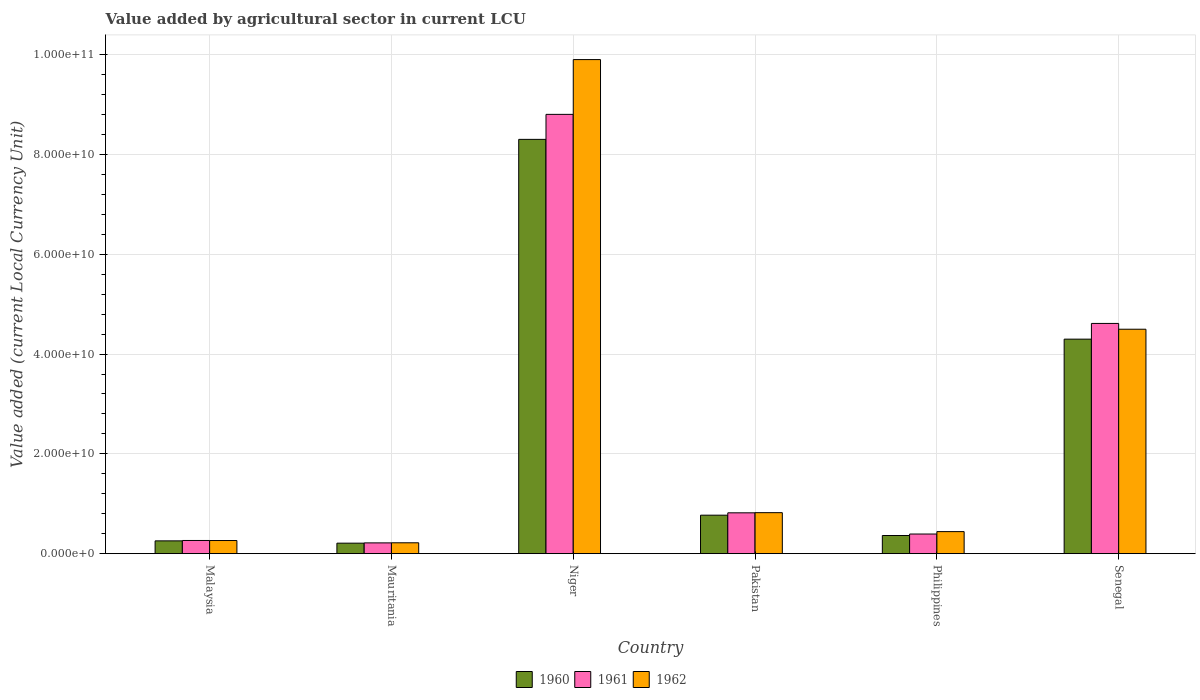How many different coloured bars are there?
Provide a short and direct response. 3. How many bars are there on the 6th tick from the right?
Your answer should be compact. 3. What is the label of the 3rd group of bars from the left?
Keep it short and to the point. Niger. In how many cases, is the number of bars for a given country not equal to the number of legend labels?
Your response must be concise. 0. What is the value added by agricultural sector in 1962 in Malaysia?
Keep it short and to the point. 2.63e+09. Across all countries, what is the maximum value added by agricultural sector in 1960?
Your answer should be very brief. 8.30e+1. Across all countries, what is the minimum value added by agricultural sector in 1962?
Your answer should be very brief. 2.18e+09. In which country was the value added by agricultural sector in 1962 maximum?
Give a very brief answer. Niger. In which country was the value added by agricultural sector in 1961 minimum?
Provide a short and direct response. Mauritania. What is the total value added by agricultural sector in 1961 in the graph?
Make the answer very short. 1.51e+11. What is the difference between the value added by agricultural sector in 1962 in Pakistan and that in Senegal?
Offer a very short reply. -3.68e+1. What is the difference between the value added by agricultural sector in 1960 in Malaysia and the value added by agricultural sector in 1961 in Pakistan?
Make the answer very short. -5.62e+09. What is the average value added by agricultural sector in 1960 per country?
Ensure brevity in your answer.  2.37e+1. What is the difference between the value added by agricultural sector of/in 1962 and value added by agricultural sector of/in 1961 in Pakistan?
Give a very brief answer. 3.20e+07. What is the ratio of the value added by agricultural sector in 1962 in Mauritania to that in Senegal?
Provide a short and direct response. 0.05. Is the value added by agricultural sector in 1961 in Mauritania less than that in Senegal?
Offer a terse response. Yes. Is the difference between the value added by agricultural sector in 1962 in Malaysia and Mauritania greater than the difference between the value added by agricultural sector in 1961 in Malaysia and Mauritania?
Offer a terse response. No. What is the difference between the highest and the second highest value added by agricultural sector in 1962?
Make the answer very short. 5.40e+1. What is the difference between the highest and the lowest value added by agricultural sector in 1960?
Give a very brief answer. 8.09e+1. What does the 2nd bar from the left in Niger represents?
Offer a terse response. 1961. Is it the case that in every country, the sum of the value added by agricultural sector in 1962 and value added by agricultural sector in 1961 is greater than the value added by agricultural sector in 1960?
Give a very brief answer. Yes. Are all the bars in the graph horizontal?
Provide a short and direct response. No. How many countries are there in the graph?
Give a very brief answer. 6. Are the values on the major ticks of Y-axis written in scientific E-notation?
Ensure brevity in your answer.  Yes. Does the graph contain grids?
Make the answer very short. Yes. Where does the legend appear in the graph?
Your response must be concise. Bottom center. What is the title of the graph?
Give a very brief answer. Value added by agricultural sector in current LCU. Does "1967" appear as one of the legend labels in the graph?
Provide a short and direct response. No. What is the label or title of the Y-axis?
Give a very brief answer. Value added (current Local Currency Unit). What is the Value added (current Local Currency Unit) of 1960 in Malaysia?
Offer a very short reply. 2.56e+09. What is the Value added (current Local Currency Unit) of 1961 in Malaysia?
Provide a short and direct response. 2.64e+09. What is the Value added (current Local Currency Unit) in 1962 in Malaysia?
Offer a terse response. 2.63e+09. What is the Value added (current Local Currency Unit) of 1960 in Mauritania?
Offer a terse response. 2.10e+09. What is the Value added (current Local Currency Unit) of 1961 in Mauritania?
Keep it short and to the point. 2.16e+09. What is the Value added (current Local Currency Unit) in 1962 in Mauritania?
Your answer should be compact. 2.18e+09. What is the Value added (current Local Currency Unit) in 1960 in Niger?
Make the answer very short. 8.30e+1. What is the Value added (current Local Currency Unit) in 1961 in Niger?
Make the answer very short. 8.80e+1. What is the Value added (current Local Currency Unit) in 1962 in Niger?
Make the answer very short. 9.90e+1. What is the Value added (current Local Currency Unit) in 1960 in Pakistan?
Keep it short and to the point. 7.71e+09. What is the Value added (current Local Currency Unit) of 1961 in Pakistan?
Offer a very short reply. 8.18e+09. What is the Value added (current Local Currency Unit) in 1962 in Pakistan?
Your answer should be compact. 8.22e+09. What is the Value added (current Local Currency Unit) of 1960 in Philippines?
Give a very brief answer. 3.64e+09. What is the Value added (current Local Currency Unit) of 1961 in Philippines?
Provide a short and direct response. 3.94e+09. What is the Value added (current Local Currency Unit) in 1962 in Philippines?
Offer a terse response. 4.42e+09. What is the Value added (current Local Currency Unit) of 1960 in Senegal?
Ensure brevity in your answer.  4.30e+1. What is the Value added (current Local Currency Unit) of 1961 in Senegal?
Offer a terse response. 4.61e+1. What is the Value added (current Local Currency Unit) of 1962 in Senegal?
Your answer should be very brief. 4.50e+1. Across all countries, what is the maximum Value added (current Local Currency Unit) of 1960?
Provide a short and direct response. 8.30e+1. Across all countries, what is the maximum Value added (current Local Currency Unit) of 1961?
Make the answer very short. 8.80e+1. Across all countries, what is the maximum Value added (current Local Currency Unit) of 1962?
Provide a short and direct response. 9.90e+1. Across all countries, what is the minimum Value added (current Local Currency Unit) of 1960?
Your answer should be compact. 2.10e+09. Across all countries, what is the minimum Value added (current Local Currency Unit) of 1961?
Provide a short and direct response. 2.16e+09. Across all countries, what is the minimum Value added (current Local Currency Unit) in 1962?
Your answer should be very brief. 2.18e+09. What is the total Value added (current Local Currency Unit) in 1960 in the graph?
Your answer should be compact. 1.42e+11. What is the total Value added (current Local Currency Unit) in 1961 in the graph?
Your answer should be compact. 1.51e+11. What is the total Value added (current Local Currency Unit) of 1962 in the graph?
Offer a very short reply. 1.61e+11. What is the difference between the Value added (current Local Currency Unit) of 1960 in Malaysia and that in Mauritania?
Give a very brief answer. 4.61e+08. What is the difference between the Value added (current Local Currency Unit) in 1961 in Malaysia and that in Mauritania?
Your answer should be very brief. 4.82e+08. What is the difference between the Value added (current Local Currency Unit) in 1962 in Malaysia and that in Mauritania?
Your answer should be compact. 4.54e+08. What is the difference between the Value added (current Local Currency Unit) of 1960 in Malaysia and that in Niger?
Your answer should be compact. -8.05e+1. What is the difference between the Value added (current Local Currency Unit) of 1961 in Malaysia and that in Niger?
Provide a short and direct response. -8.54e+1. What is the difference between the Value added (current Local Currency Unit) of 1962 in Malaysia and that in Niger?
Give a very brief answer. -9.64e+1. What is the difference between the Value added (current Local Currency Unit) of 1960 in Malaysia and that in Pakistan?
Provide a succinct answer. -5.15e+09. What is the difference between the Value added (current Local Currency Unit) of 1961 in Malaysia and that in Pakistan?
Your response must be concise. -5.54e+09. What is the difference between the Value added (current Local Currency Unit) in 1962 in Malaysia and that in Pakistan?
Provide a short and direct response. -5.58e+09. What is the difference between the Value added (current Local Currency Unit) in 1960 in Malaysia and that in Philippines?
Provide a short and direct response. -1.07e+09. What is the difference between the Value added (current Local Currency Unit) in 1961 in Malaysia and that in Philippines?
Keep it short and to the point. -1.29e+09. What is the difference between the Value added (current Local Currency Unit) of 1962 in Malaysia and that in Philippines?
Ensure brevity in your answer.  -1.78e+09. What is the difference between the Value added (current Local Currency Unit) in 1960 in Malaysia and that in Senegal?
Keep it short and to the point. -4.04e+1. What is the difference between the Value added (current Local Currency Unit) in 1961 in Malaysia and that in Senegal?
Provide a short and direct response. -4.35e+1. What is the difference between the Value added (current Local Currency Unit) of 1962 in Malaysia and that in Senegal?
Provide a short and direct response. -4.23e+1. What is the difference between the Value added (current Local Currency Unit) in 1960 in Mauritania and that in Niger?
Ensure brevity in your answer.  -8.09e+1. What is the difference between the Value added (current Local Currency Unit) of 1961 in Mauritania and that in Niger?
Give a very brief answer. -8.59e+1. What is the difference between the Value added (current Local Currency Unit) of 1962 in Mauritania and that in Niger?
Offer a terse response. -9.68e+1. What is the difference between the Value added (current Local Currency Unit) of 1960 in Mauritania and that in Pakistan?
Keep it short and to the point. -5.61e+09. What is the difference between the Value added (current Local Currency Unit) of 1961 in Mauritania and that in Pakistan?
Your answer should be compact. -6.02e+09. What is the difference between the Value added (current Local Currency Unit) in 1962 in Mauritania and that in Pakistan?
Keep it short and to the point. -6.04e+09. What is the difference between the Value added (current Local Currency Unit) of 1960 in Mauritania and that in Philippines?
Your response must be concise. -1.54e+09. What is the difference between the Value added (current Local Currency Unit) in 1961 in Mauritania and that in Philippines?
Your answer should be very brief. -1.78e+09. What is the difference between the Value added (current Local Currency Unit) in 1962 in Mauritania and that in Philippines?
Provide a succinct answer. -2.24e+09. What is the difference between the Value added (current Local Currency Unit) in 1960 in Mauritania and that in Senegal?
Offer a terse response. -4.09e+1. What is the difference between the Value added (current Local Currency Unit) of 1961 in Mauritania and that in Senegal?
Give a very brief answer. -4.40e+1. What is the difference between the Value added (current Local Currency Unit) in 1962 in Mauritania and that in Senegal?
Give a very brief answer. -4.28e+1. What is the difference between the Value added (current Local Currency Unit) in 1960 in Niger and that in Pakistan?
Keep it short and to the point. 7.53e+1. What is the difference between the Value added (current Local Currency Unit) in 1961 in Niger and that in Pakistan?
Provide a succinct answer. 7.98e+1. What is the difference between the Value added (current Local Currency Unit) in 1962 in Niger and that in Pakistan?
Provide a short and direct response. 9.08e+1. What is the difference between the Value added (current Local Currency Unit) in 1960 in Niger and that in Philippines?
Your answer should be very brief. 7.94e+1. What is the difference between the Value added (current Local Currency Unit) in 1961 in Niger and that in Philippines?
Your answer should be very brief. 8.41e+1. What is the difference between the Value added (current Local Currency Unit) in 1962 in Niger and that in Philippines?
Offer a terse response. 9.46e+1. What is the difference between the Value added (current Local Currency Unit) of 1960 in Niger and that in Senegal?
Your answer should be compact. 4.00e+1. What is the difference between the Value added (current Local Currency Unit) of 1961 in Niger and that in Senegal?
Your answer should be compact. 4.19e+1. What is the difference between the Value added (current Local Currency Unit) of 1962 in Niger and that in Senegal?
Your answer should be compact. 5.40e+1. What is the difference between the Value added (current Local Currency Unit) in 1960 in Pakistan and that in Philippines?
Give a very brief answer. 4.07e+09. What is the difference between the Value added (current Local Currency Unit) of 1961 in Pakistan and that in Philippines?
Offer a very short reply. 4.25e+09. What is the difference between the Value added (current Local Currency Unit) of 1962 in Pakistan and that in Philippines?
Your answer should be compact. 3.80e+09. What is the difference between the Value added (current Local Currency Unit) of 1960 in Pakistan and that in Senegal?
Your answer should be compact. -3.53e+1. What is the difference between the Value added (current Local Currency Unit) in 1961 in Pakistan and that in Senegal?
Offer a very short reply. -3.80e+1. What is the difference between the Value added (current Local Currency Unit) of 1962 in Pakistan and that in Senegal?
Provide a succinct answer. -3.68e+1. What is the difference between the Value added (current Local Currency Unit) of 1960 in Philippines and that in Senegal?
Offer a very short reply. -3.94e+1. What is the difference between the Value added (current Local Currency Unit) of 1961 in Philippines and that in Senegal?
Provide a succinct answer. -4.22e+1. What is the difference between the Value added (current Local Currency Unit) in 1962 in Philippines and that in Senegal?
Make the answer very short. -4.06e+1. What is the difference between the Value added (current Local Currency Unit) in 1960 in Malaysia and the Value added (current Local Currency Unit) in 1961 in Mauritania?
Offer a very short reply. 4.04e+08. What is the difference between the Value added (current Local Currency Unit) in 1960 in Malaysia and the Value added (current Local Currency Unit) in 1962 in Mauritania?
Your answer should be compact. 3.86e+08. What is the difference between the Value added (current Local Currency Unit) of 1961 in Malaysia and the Value added (current Local Currency Unit) of 1962 in Mauritania?
Your response must be concise. 4.63e+08. What is the difference between the Value added (current Local Currency Unit) in 1960 in Malaysia and the Value added (current Local Currency Unit) in 1961 in Niger?
Your answer should be compact. -8.55e+1. What is the difference between the Value added (current Local Currency Unit) of 1960 in Malaysia and the Value added (current Local Currency Unit) of 1962 in Niger?
Make the answer very short. -9.64e+1. What is the difference between the Value added (current Local Currency Unit) in 1961 in Malaysia and the Value added (current Local Currency Unit) in 1962 in Niger?
Your answer should be very brief. -9.64e+1. What is the difference between the Value added (current Local Currency Unit) of 1960 in Malaysia and the Value added (current Local Currency Unit) of 1961 in Pakistan?
Your answer should be compact. -5.62e+09. What is the difference between the Value added (current Local Currency Unit) in 1960 in Malaysia and the Value added (current Local Currency Unit) in 1962 in Pakistan?
Your answer should be compact. -5.65e+09. What is the difference between the Value added (current Local Currency Unit) of 1961 in Malaysia and the Value added (current Local Currency Unit) of 1962 in Pakistan?
Your answer should be compact. -5.57e+09. What is the difference between the Value added (current Local Currency Unit) of 1960 in Malaysia and the Value added (current Local Currency Unit) of 1961 in Philippines?
Offer a terse response. -1.37e+09. What is the difference between the Value added (current Local Currency Unit) of 1960 in Malaysia and the Value added (current Local Currency Unit) of 1962 in Philippines?
Your answer should be very brief. -1.85e+09. What is the difference between the Value added (current Local Currency Unit) in 1961 in Malaysia and the Value added (current Local Currency Unit) in 1962 in Philippines?
Ensure brevity in your answer.  -1.77e+09. What is the difference between the Value added (current Local Currency Unit) of 1960 in Malaysia and the Value added (current Local Currency Unit) of 1961 in Senegal?
Provide a short and direct response. -4.36e+1. What is the difference between the Value added (current Local Currency Unit) of 1960 in Malaysia and the Value added (current Local Currency Unit) of 1962 in Senegal?
Your answer should be compact. -4.24e+1. What is the difference between the Value added (current Local Currency Unit) of 1961 in Malaysia and the Value added (current Local Currency Unit) of 1962 in Senegal?
Provide a succinct answer. -4.23e+1. What is the difference between the Value added (current Local Currency Unit) in 1960 in Mauritania and the Value added (current Local Currency Unit) in 1961 in Niger?
Your answer should be compact. -8.59e+1. What is the difference between the Value added (current Local Currency Unit) in 1960 in Mauritania and the Value added (current Local Currency Unit) in 1962 in Niger?
Keep it short and to the point. -9.69e+1. What is the difference between the Value added (current Local Currency Unit) in 1961 in Mauritania and the Value added (current Local Currency Unit) in 1962 in Niger?
Your answer should be very brief. -9.69e+1. What is the difference between the Value added (current Local Currency Unit) in 1960 in Mauritania and the Value added (current Local Currency Unit) in 1961 in Pakistan?
Offer a terse response. -6.08e+09. What is the difference between the Value added (current Local Currency Unit) of 1960 in Mauritania and the Value added (current Local Currency Unit) of 1962 in Pakistan?
Make the answer very short. -6.11e+09. What is the difference between the Value added (current Local Currency Unit) of 1961 in Mauritania and the Value added (current Local Currency Unit) of 1962 in Pakistan?
Ensure brevity in your answer.  -6.06e+09. What is the difference between the Value added (current Local Currency Unit) in 1960 in Mauritania and the Value added (current Local Currency Unit) in 1961 in Philippines?
Your answer should be very brief. -1.83e+09. What is the difference between the Value added (current Local Currency Unit) in 1960 in Mauritania and the Value added (current Local Currency Unit) in 1962 in Philippines?
Ensure brevity in your answer.  -2.31e+09. What is the difference between the Value added (current Local Currency Unit) in 1961 in Mauritania and the Value added (current Local Currency Unit) in 1962 in Philippines?
Make the answer very short. -2.26e+09. What is the difference between the Value added (current Local Currency Unit) of 1960 in Mauritania and the Value added (current Local Currency Unit) of 1961 in Senegal?
Provide a succinct answer. -4.40e+1. What is the difference between the Value added (current Local Currency Unit) of 1960 in Mauritania and the Value added (current Local Currency Unit) of 1962 in Senegal?
Make the answer very short. -4.29e+1. What is the difference between the Value added (current Local Currency Unit) in 1961 in Mauritania and the Value added (current Local Currency Unit) in 1962 in Senegal?
Offer a terse response. -4.28e+1. What is the difference between the Value added (current Local Currency Unit) of 1960 in Niger and the Value added (current Local Currency Unit) of 1961 in Pakistan?
Ensure brevity in your answer.  7.48e+1. What is the difference between the Value added (current Local Currency Unit) of 1960 in Niger and the Value added (current Local Currency Unit) of 1962 in Pakistan?
Give a very brief answer. 7.48e+1. What is the difference between the Value added (current Local Currency Unit) of 1961 in Niger and the Value added (current Local Currency Unit) of 1962 in Pakistan?
Your answer should be compact. 7.98e+1. What is the difference between the Value added (current Local Currency Unit) in 1960 in Niger and the Value added (current Local Currency Unit) in 1961 in Philippines?
Your answer should be very brief. 7.91e+1. What is the difference between the Value added (current Local Currency Unit) of 1960 in Niger and the Value added (current Local Currency Unit) of 1962 in Philippines?
Offer a very short reply. 7.86e+1. What is the difference between the Value added (current Local Currency Unit) in 1961 in Niger and the Value added (current Local Currency Unit) in 1962 in Philippines?
Provide a succinct answer. 8.36e+1. What is the difference between the Value added (current Local Currency Unit) of 1960 in Niger and the Value added (current Local Currency Unit) of 1961 in Senegal?
Give a very brief answer. 3.69e+1. What is the difference between the Value added (current Local Currency Unit) of 1960 in Niger and the Value added (current Local Currency Unit) of 1962 in Senegal?
Ensure brevity in your answer.  3.80e+1. What is the difference between the Value added (current Local Currency Unit) of 1961 in Niger and the Value added (current Local Currency Unit) of 1962 in Senegal?
Make the answer very short. 4.31e+1. What is the difference between the Value added (current Local Currency Unit) of 1960 in Pakistan and the Value added (current Local Currency Unit) of 1961 in Philippines?
Give a very brief answer. 3.78e+09. What is the difference between the Value added (current Local Currency Unit) of 1960 in Pakistan and the Value added (current Local Currency Unit) of 1962 in Philippines?
Provide a short and direct response. 3.29e+09. What is the difference between the Value added (current Local Currency Unit) of 1961 in Pakistan and the Value added (current Local Currency Unit) of 1962 in Philippines?
Give a very brief answer. 3.77e+09. What is the difference between the Value added (current Local Currency Unit) of 1960 in Pakistan and the Value added (current Local Currency Unit) of 1961 in Senegal?
Your response must be concise. -3.84e+1. What is the difference between the Value added (current Local Currency Unit) of 1960 in Pakistan and the Value added (current Local Currency Unit) of 1962 in Senegal?
Make the answer very short. -3.73e+1. What is the difference between the Value added (current Local Currency Unit) of 1961 in Pakistan and the Value added (current Local Currency Unit) of 1962 in Senegal?
Offer a very short reply. -3.68e+1. What is the difference between the Value added (current Local Currency Unit) in 1960 in Philippines and the Value added (current Local Currency Unit) in 1961 in Senegal?
Your answer should be compact. -4.25e+1. What is the difference between the Value added (current Local Currency Unit) of 1960 in Philippines and the Value added (current Local Currency Unit) of 1962 in Senegal?
Offer a very short reply. -4.13e+1. What is the difference between the Value added (current Local Currency Unit) of 1961 in Philippines and the Value added (current Local Currency Unit) of 1962 in Senegal?
Provide a short and direct response. -4.10e+1. What is the average Value added (current Local Currency Unit) of 1960 per country?
Ensure brevity in your answer.  2.37e+1. What is the average Value added (current Local Currency Unit) in 1961 per country?
Offer a very short reply. 2.52e+1. What is the average Value added (current Local Currency Unit) in 1962 per country?
Provide a short and direct response. 2.69e+1. What is the difference between the Value added (current Local Currency Unit) of 1960 and Value added (current Local Currency Unit) of 1961 in Malaysia?
Your answer should be very brief. -7.78e+07. What is the difference between the Value added (current Local Currency Unit) of 1960 and Value added (current Local Currency Unit) of 1962 in Malaysia?
Your response must be concise. -6.83e+07. What is the difference between the Value added (current Local Currency Unit) of 1961 and Value added (current Local Currency Unit) of 1962 in Malaysia?
Your answer should be compact. 9.46e+06. What is the difference between the Value added (current Local Currency Unit) of 1960 and Value added (current Local Currency Unit) of 1961 in Mauritania?
Ensure brevity in your answer.  -5.68e+07. What is the difference between the Value added (current Local Currency Unit) of 1960 and Value added (current Local Currency Unit) of 1962 in Mauritania?
Your response must be concise. -7.58e+07. What is the difference between the Value added (current Local Currency Unit) in 1961 and Value added (current Local Currency Unit) in 1962 in Mauritania?
Offer a very short reply. -1.89e+07. What is the difference between the Value added (current Local Currency Unit) in 1960 and Value added (current Local Currency Unit) in 1961 in Niger?
Make the answer very short. -5.01e+09. What is the difference between the Value added (current Local Currency Unit) of 1960 and Value added (current Local Currency Unit) of 1962 in Niger?
Your response must be concise. -1.60e+1. What is the difference between the Value added (current Local Currency Unit) in 1961 and Value added (current Local Currency Unit) in 1962 in Niger?
Offer a very short reply. -1.10e+1. What is the difference between the Value added (current Local Currency Unit) of 1960 and Value added (current Local Currency Unit) of 1961 in Pakistan?
Provide a succinct answer. -4.73e+08. What is the difference between the Value added (current Local Currency Unit) in 1960 and Value added (current Local Currency Unit) in 1962 in Pakistan?
Your answer should be compact. -5.05e+08. What is the difference between the Value added (current Local Currency Unit) of 1961 and Value added (current Local Currency Unit) of 1962 in Pakistan?
Give a very brief answer. -3.20e+07. What is the difference between the Value added (current Local Currency Unit) in 1960 and Value added (current Local Currency Unit) in 1961 in Philippines?
Keep it short and to the point. -2.97e+08. What is the difference between the Value added (current Local Currency Unit) of 1960 and Value added (current Local Currency Unit) of 1962 in Philippines?
Offer a very short reply. -7.78e+08. What is the difference between the Value added (current Local Currency Unit) of 1961 and Value added (current Local Currency Unit) of 1962 in Philippines?
Provide a succinct answer. -4.81e+08. What is the difference between the Value added (current Local Currency Unit) in 1960 and Value added (current Local Currency Unit) in 1961 in Senegal?
Keep it short and to the point. -3.15e+09. What is the difference between the Value added (current Local Currency Unit) in 1960 and Value added (current Local Currency Unit) in 1962 in Senegal?
Make the answer very short. -1.99e+09. What is the difference between the Value added (current Local Currency Unit) of 1961 and Value added (current Local Currency Unit) of 1962 in Senegal?
Offer a very short reply. 1.16e+09. What is the ratio of the Value added (current Local Currency Unit) in 1960 in Malaysia to that in Mauritania?
Give a very brief answer. 1.22. What is the ratio of the Value added (current Local Currency Unit) of 1961 in Malaysia to that in Mauritania?
Ensure brevity in your answer.  1.22. What is the ratio of the Value added (current Local Currency Unit) in 1962 in Malaysia to that in Mauritania?
Provide a succinct answer. 1.21. What is the ratio of the Value added (current Local Currency Unit) of 1960 in Malaysia to that in Niger?
Give a very brief answer. 0.03. What is the ratio of the Value added (current Local Currency Unit) of 1961 in Malaysia to that in Niger?
Provide a short and direct response. 0.03. What is the ratio of the Value added (current Local Currency Unit) of 1962 in Malaysia to that in Niger?
Ensure brevity in your answer.  0.03. What is the ratio of the Value added (current Local Currency Unit) in 1960 in Malaysia to that in Pakistan?
Your response must be concise. 0.33. What is the ratio of the Value added (current Local Currency Unit) of 1961 in Malaysia to that in Pakistan?
Offer a terse response. 0.32. What is the ratio of the Value added (current Local Currency Unit) in 1962 in Malaysia to that in Pakistan?
Offer a very short reply. 0.32. What is the ratio of the Value added (current Local Currency Unit) in 1960 in Malaysia to that in Philippines?
Ensure brevity in your answer.  0.7. What is the ratio of the Value added (current Local Currency Unit) in 1961 in Malaysia to that in Philippines?
Offer a terse response. 0.67. What is the ratio of the Value added (current Local Currency Unit) of 1962 in Malaysia to that in Philippines?
Provide a succinct answer. 0.6. What is the ratio of the Value added (current Local Currency Unit) in 1960 in Malaysia to that in Senegal?
Offer a very short reply. 0.06. What is the ratio of the Value added (current Local Currency Unit) of 1961 in Malaysia to that in Senegal?
Your answer should be very brief. 0.06. What is the ratio of the Value added (current Local Currency Unit) in 1962 in Malaysia to that in Senegal?
Give a very brief answer. 0.06. What is the ratio of the Value added (current Local Currency Unit) of 1960 in Mauritania to that in Niger?
Give a very brief answer. 0.03. What is the ratio of the Value added (current Local Currency Unit) of 1961 in Mauritania to that in Niger?
Your response must be concise. 0.02. What is the ratio of the Value added (current Local Currency Unit) in 1962 in Mauritania to that in Niger?
Your answer should be compact. 0.02. What is the ratio of the Value added (current Local Currency Unit) of 1960 in Mauritania to that in Pakistan?
Ensure brevity in your answer.  0.27. What is the ratio of the Value added (current Local Currency Unit) in 1961 in Mauritania to that in Pakistan?
Provide a succinct answer. 0.26. What is the ratio of the Value added (current Local Currency Unit) of 1962 in Mauritania to that in Pakistan?
Offer a terse response. 0.27. What is the ratio of the Value added (current Local Currency Unit) of 1960 in Mauritania to that in Philippines?
Offer a very short reply. 0.58. What is the ratio of the Value added (current Local Currency Unit) of 1961 in Mauritania to that in Philippines?
Make the answer very short. 0.55. What is the ratio of the Value added (current Local Currency Unit) in 1962 in Mauritania to that in Philippines?
Your answer should be very brief. 0.49. What is the ratio of the Value added (current Local Currency Unit) in 1960 in Mauritania to that in Senegal?
Give a very brief answer. 0.05. What is the ratio of the Value added (current Local Currency Unit) of 1961 in Mauritania to that in Senegal?
Provide a short and direct response. 0.05. What is the ratio of the Value added (current Local Currency Unit) of 1962 in Mauritania to that in Senegal?
Offer a very short reply. 0.05. What is the ratio of the Value added (current Local Currency Unit) of 1960 in Niger to that in Pakistan?
Give a very brief answer. 10.77. What is the ratio of the Value added (current Local Currency Unit) of 1961 in Niger to that in Pakistan?
Offer a very short reply. 10.76. What is the ratio of the Value added (current Local Currency Unit) in 1962 in Niger to that in Pakistan?
Ensure brevity in your answer.  12.05. What is the ratio of the Value added (current Local Currency Unit) of 1960 in Niger to that in Philippines?
Offer a terse response. 22.82. What is the ratio of the Value added (current Local Currency Unit) in 1961 in Niger to that in Philippines?
Provide a succinct answer. 22.37. What is the ratio of the Value added (current Local Currency Unit) of 1962 in Niger to that in Philippines?
Your answer should be compact. 22.42. What is the ratio of the Value added (current Local Currency Unit) of 1960 in Niger to that in Senegal?
Your answer should be very brief. 1.93. What is the ratio of the Value added (current Local Currency Unit) of 1961 in Niger to that in Senegal?
Make the answer very short. 1.91. What is the ratio of the Value added (current Local Currency Unit) of 1962 in Niger to that in Senegal?
Your response must be concise. 2.2. What is the ratio of the Value added (current Local Currency Unit) in 1960 in Pakistan to that in Philippines?
Offer a very short reply. 2.12. What is the ratio of the Value added (current Local Currency Unit) of 1961 in Pakistan to that in Philippines?
Make the answer very short. 2.08. What is the ratio of the Value added (current Local Currency Unit) of 1962 in Pakistan to that in Philippines?
Provide a short and direct response. 1.86. What is the ratio of the Value added (current Local Currency Unit) in 1960 in Pakistan to that in Senegal?
Make the answer very short. 0.18. What is the ratio of the Value added (current Local Currency Unit) of 1961 in Pakistan to that in Senegal?
Ensure brevity in your answer.  0.18. What is the ratio of the Value added (current Local Currency Unit) in 1962 in Pakistan to that in Senegal?
Keep it short and to the point. 0.18. What is the ratio of the Value added (current Local Currency Unit) in 1960 in Philippines to that in Senegal?
Keep it short and to the point. 0.08. What is the ratio of the Value added (current Local Currency Unit) of 1961 in Philippines to that in Senegal?
Make the answer very short. 0.09. What is the ratio of the Value added (current Local Currency Unit) of 1962 in Philippines to that in Senegal?
Provide a succinct answer. 0.1. What is the difference between the highest and the second highest Value added (current Local Currency Unit) in 1960?
Your answer should be very brief. 4.00e+1. What is the difference between the highest and the second highest Value added (current Local Currency Unit) of 1961?
Your answer should be compact. 4.19e+1. What is the difference between the highest and the second highest Value added (current Local Currency Unit) in 1962?
Your answer should be very brief. 5.40e+1. What is the difference between the highest and the lowest Value added (current Local Currency Unit) in 1960?
Provide a short and direct response. 8.09e+1. What is the difference between the highest and the lowest Value added (current Local Currency Unit) of 1961?
Give a very brief answer. 8.59e+1. What is the difference between the highest and the lowest Value added (current Local Currency Unit) in 1962?
Make the answer very short. 9.68e+1. 